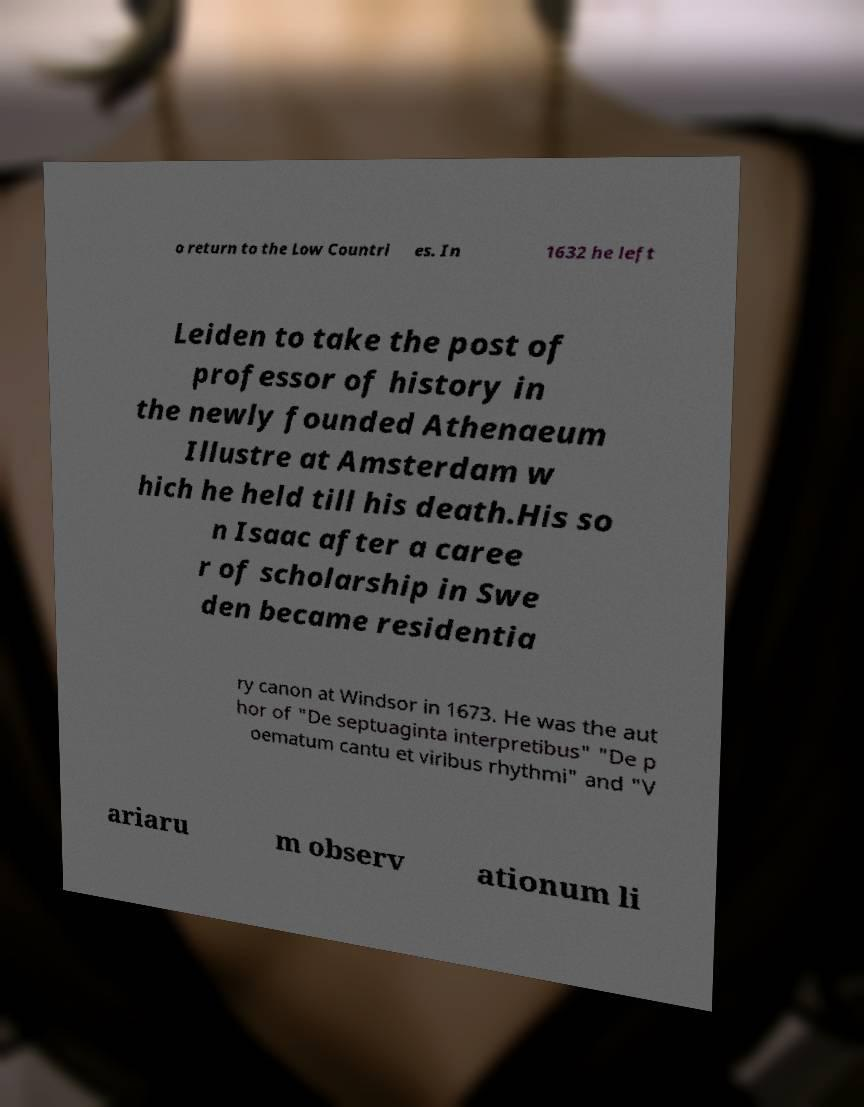Could you extract and type out the text from this image? o return to the Low Countri es. In 1632 he left Leiden to take the post of professor of history in the newly founded Athenaeum Illustre at Amsterdam w hich he held till his death.His so n Isaac after a caree r of scholarship in Swe den became residentia ry canon at Windsor in 1673. He was the aut hor of "De septuaginta interpretibus" "De p oematum cantu et viribus rhythmi" and "V ariaru m observ ationum li 